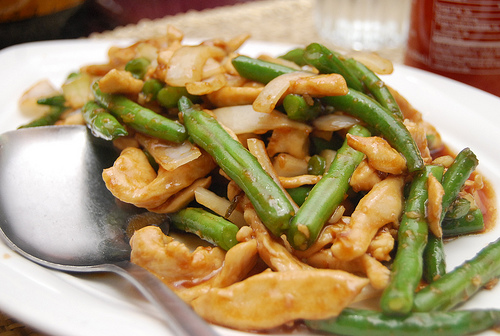<image>
Can you confirm if the spoon is on the food? Yes. Looking at the image, I can see the spoon is positioned on top of the food, with the food providing support. 